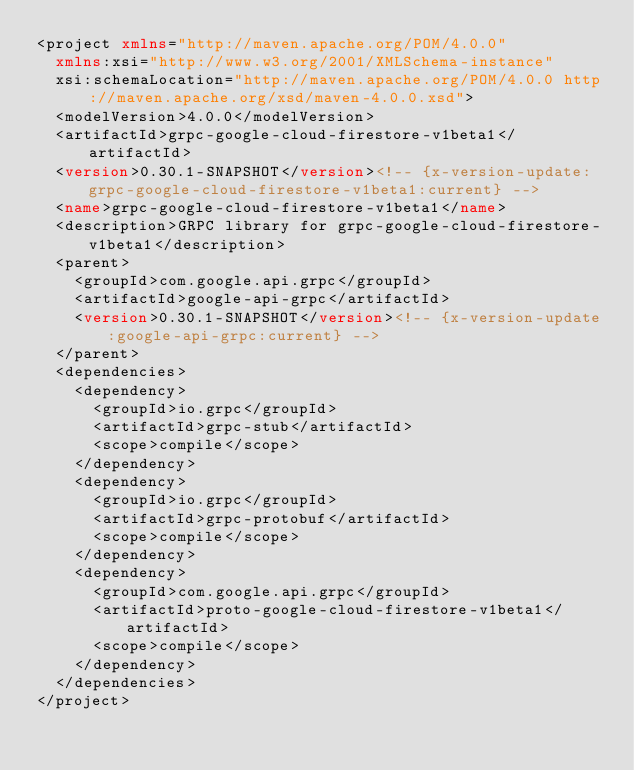Convert code to text. <code><loc_0><loc_0><loc_500><loc_500><_XML_><project xmlns="http://maven.apache.org/POM/4.0.0"
  xmlns:xsi="http://www.w3.org/2001/XMLSchema-instance"
  xsi:schemaLocation="http://maven.apache.org/POM/4.0.0 http://maven.apache.org/xsd/maven-4.0.0.xsd">
  <modelVersion>4.0.0</modelVersion>
  <artifactId>grpc-google-cloud-firestore-v1beta1</artifactId>
  <version>0.30.1-SNAPSHOT</version><!-- {x-version-update:grpc-google-cloud-firestore-v1beta1:current} -->
  <name>grpc-google-cloud-firestore-v1beta1</name>
  <description>GRPC library for grpc-google-cloud-firestore-v1beta1</description>
  <parent>
    <groupId>com.google.api.grpc</groupId>
    <artifactId>google-api-grpc</artifactId>
    <version>0.30.1-SNAPSHOT</version><!-- {x-version-update:google-api-grpc:current} -->
  </parent>
  <dependencies>
    <dependency>
      <groupId>io.grpc</groupId>
      <artifactId>grpc-stub</artifactId>
      <scope>compile</scope>
    </dependency>
    <dependency>
      <groupId>io.grpc</groupId>
      <artifactId>grpc-protobuf</artifactId>
      <scope>compile</scope>
    </dependency>
    <dependency>
      <groupId>com.google.api.grpc</groupId>
      <artifactId>proto-google-cloud-firestore-v1beta1</artifactId>
      <scope>compile</scope>
    </dependency>
  </dependencies>
</project></code> 